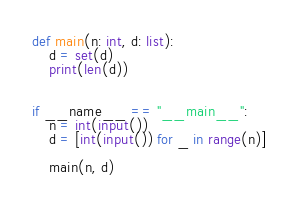Convert code to text. <code><loc_0><loc_0><loc_500><loc_500><_Python_>def main(n: int, d: list):
    d = set(d)
    print(len(d))


if __name__ == "__main__":
    n = int(input())
    d = [int(input()) for _ in range(n)]

    main(n, d)
</code> 